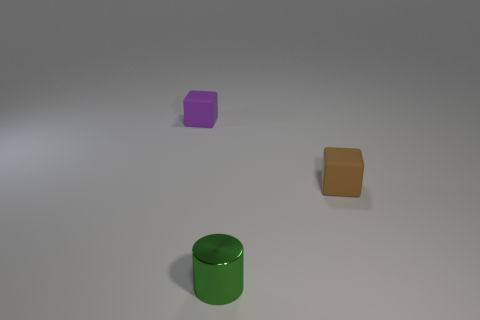Add 3 tiny shiny things. How many objects exist? 6 Subtract all blocks. How many objects are left? 1 Add 3 blue blocks. How many blue blocks exist? 3 Subtract 0 purple cylinders. How many objects are left? 3 Subtract all big blue metallic objects. Subtract all metallic things. How many objects are left? 2 Add 3 purple rubber cubes. How many purple rubber cubes are left? 4 